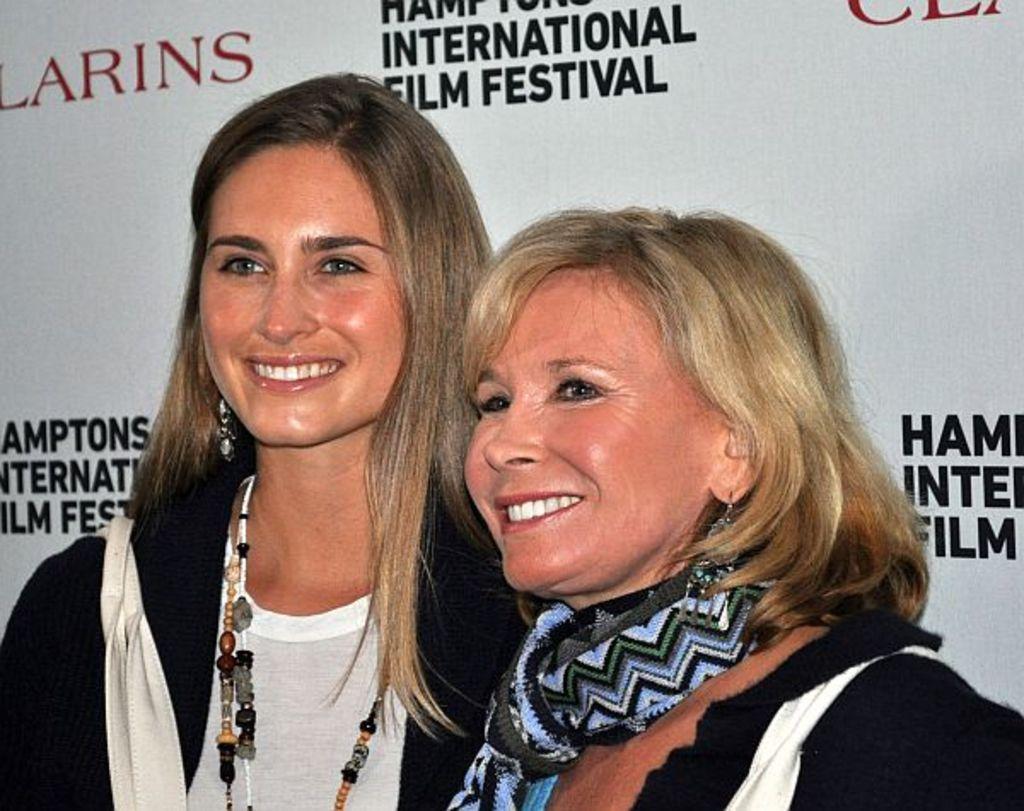Can you describe this image briefly? In this image there are two women with a smile on their face, behind them there is a banner with some text on it. 